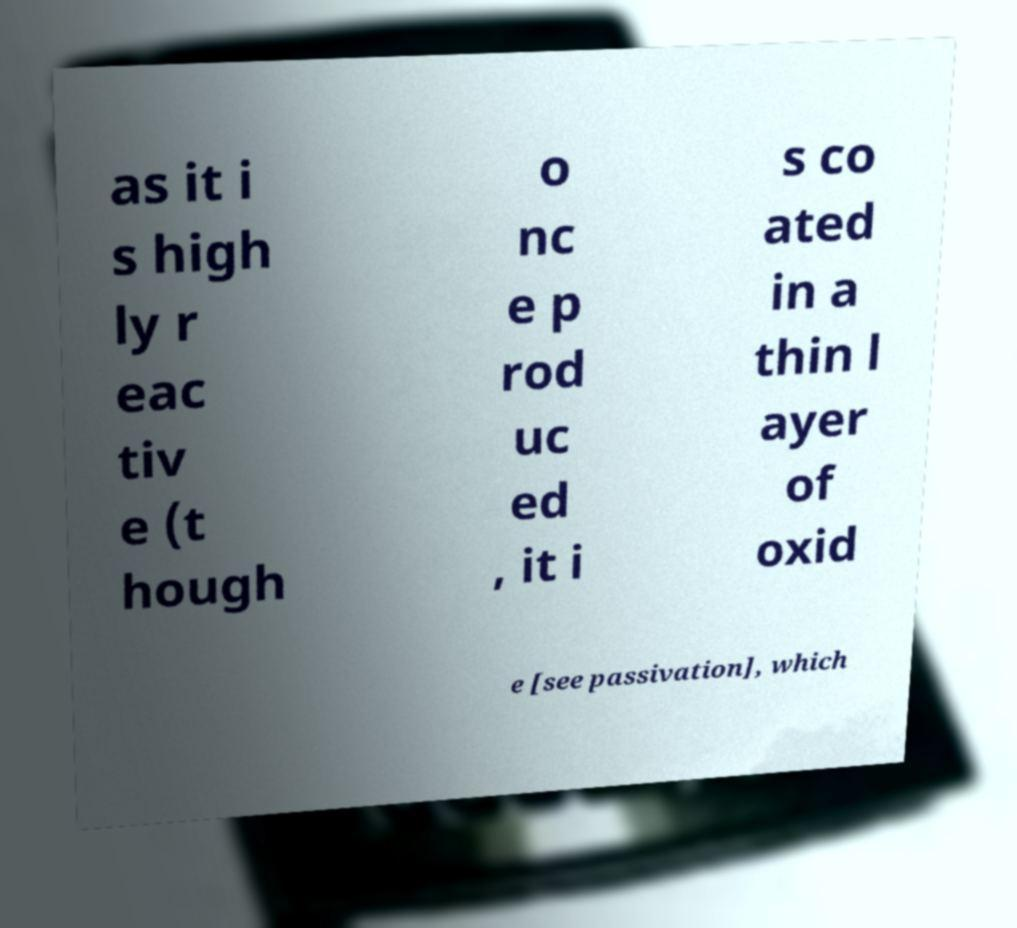I need the written content from this picture converted into text. Can you do that? as it i s high ly r eac tiv e (t hough o nc e p rod uc ed , it i s co ated in a thin l ayer of oxid e [see passivation], which 